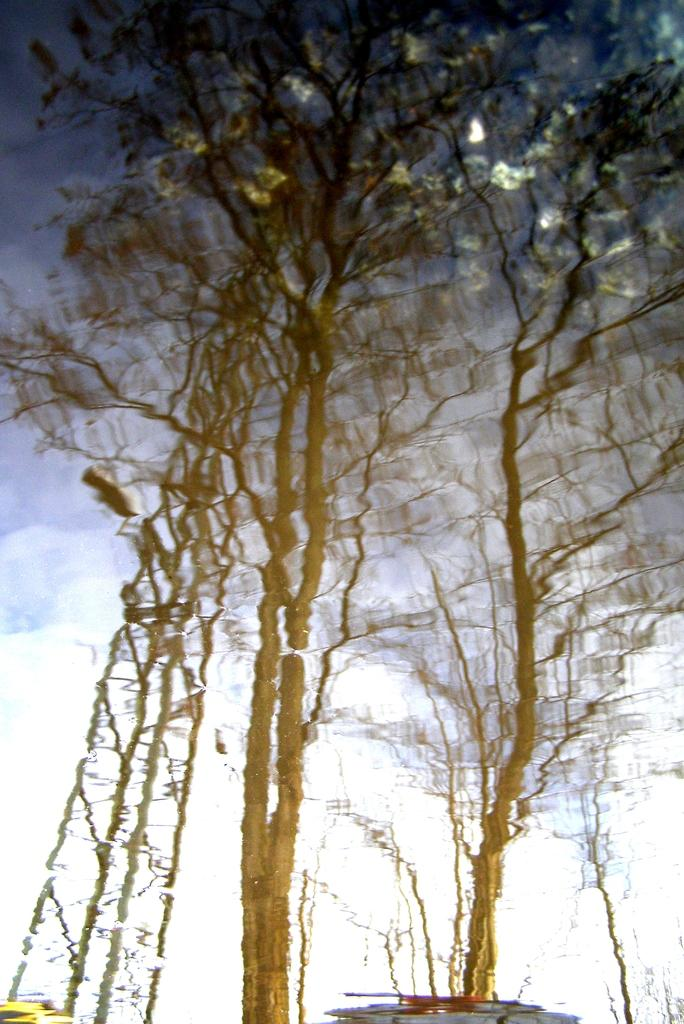What type of natural elements can be seen in the image? There are trees in the image. What color scheme is present in some areas of the image? The image has a white color scheme in some areas. What color scheme is present in other areas of the image? The image has a dark color scheme in some areas. What type of texture can be felt on the glove in the image? There is no glove present in the image, so it is not possible to determine the texture of a glove. 